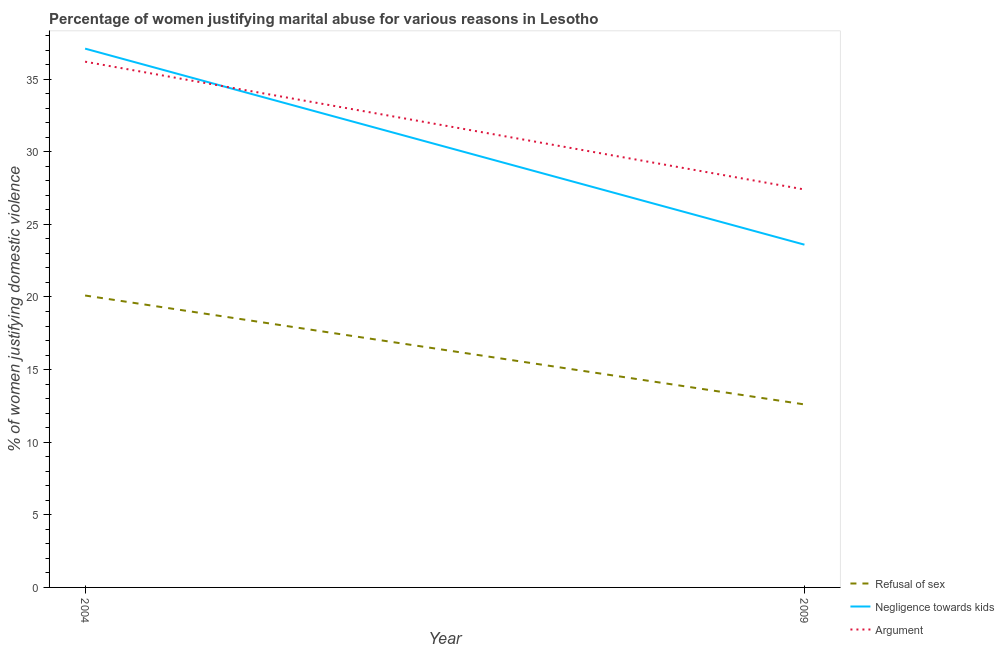How many different coloured lines are there?
Your answer should be very brief. 3. Does the line corresponding to percentage of women justifying domestic violence due to arguments intersect with the line corresponding to percentage of women justifying domestic violence due to negligence towards kids?
Provide a succinct answer. Yes. What is the percentage of women justifying domestic violence due to negligence towards kids in 2004?
Provide a succinct answer. 37.1. Across all years, what is the maximum percentage of women justifying domestic violence due to refusal of sex?
Provide a short and direct response. 20.1. Across all years, what is the minimum percentage of women justifying domestic violence due to arguments?
Offer a terse response. 27.4. In which year was the percentage of women justifying domestic violence due to refusal of sex minimum?
Your response must be concise. 2009. What is the total percentage of women justifying domestic violence due to negligence towards kids in the graph?
Offer a very short reply. 60.7. What is the difference between the percentage of women justifying domestic violence due to negligence towards kids in 2004 and that in 2009?
Keep it short and to the point. 13.5. What is the average percentage of women justifying domestic violence due to negligence towards kids per year?
Offer a terse response. 30.35. In the year 2004, what is the difference between the percentage of women justifying domestic violence due to negligence towards kids and percentage of women justifying domestic violence due to arguments?
Provide a succinct answer. 0.9. What is the ratio of the percentage of women justifying domestic violence due to refusal of sex in 2004 to that in 2009?
Make the answer very short. 1.6. Is the percentage of women justifying domestic violence due to refusal of sex in 2004 less than that in 2009?
Your response must be concise. No. In how many years, is the percentage of women justifying domestic violence due to negligence towards kids greater than the average percentage of women justifying domestic violence due to negligence towards kids taken over all years?
Provide a succinct answer. 1. Does the percentage of women justifying domestic violence due to negligence towards kids monotonically increase over the years?
Keep it short and to the point. No. Is the percentage of women justifying domestic violence due to arguments strictly greater than the percentage of women justifying domestic violence due to negligence towards kids over the years?
Offer a terse response. No. Is the percentage of women justifying domestic violence due to refusal of sex strictly less than the percentage of women justifying domestic violence due to arguments over the years?
Provide a succinct answer. Yes. How many years are there in the graph?
Your response must be concise. 2. Where does the legend appear in the graph?
Give a very brief answer. Bottom right. How many legend labels are there?
Provide a short and direct response. 3. What is the title of the graph?
Make the answer very short. Percentage of women justifying marital abuse for various reasons in Lesotho. Does "Total employers" appear as one of the legend labels in the graph?
Provide a short and direct response. No. What is the label or title of the Y-axis?
Offer a terse response. % of women justifying domestic violence. What is the % of women justifying domestic violence in Refusal of sex in 2004?
Ensure brevity in your answer.  20.1. What is the % of women justifying domestic violence in Negligence towards kids in 2004?
Provide a short and direct response. 37.1. What is the % of women justifying domestic violence of Argument in 2004?
Your response must be concise. 36.2. What is the % of women justifying domestic violence of Refusal of sex in 2009?
Give a very brief answer. 12.6. What is the % of women justifying domestic violence in Negligence towards kids in 2009?
Your response must be concise. 23.6. What is the % of women justifying domestic violence of Argument in 2009?
Offer a terse response. 27.4. Across all years, what is the maximum % of women justifying domestic violence of Refusal of sex?
Provide a short and direct response. 20.1. Across all years, what is the maximum % of women justifying domestic violence of Negligence towards kids?
Your response must be concise. 37.1. Across all years, what is the maximum % of women justifying domestic violence of Argument?
Give a very brief answer. 36.2. Across all years, what is the minimum % of women justifying domestic violence in Refusal of sex?
Your answer should be compact. 12.6. Across all years, what is the minimum % of women justifying domestic violence of Negligence towards kids?
Your answer should be compact. 23.6. Across all years, what is the minimum % of women justifying domestic violence of Argument?
Keep it short and to the point. 27.4. What is the total % of women justifying domestic violence of Refusal of sex in the graph?
Offer a very short reply. 32.7. What is the total % of women justifying domestic violence in Negligence towards kids in the graph?
Your answer should be very brief. 60.7. What is the total % of women justifying domestic violence of Argument in the graph?
Offer a very short reply. 63.6. What is the difference between the % of women justifying domestic violence in Refusal of sex in 2004 and that in 2009?
Provide a succinct answer. 7.5. What is the difference between the % of women justifying domestic violence in Negligence towards kids in 2004 and that in 2009?
Ensure brevity in your answer.  13.5. What is the difference between the % of women justifying domestic violence in Refusal of sex in 2004 and the % of women justifying domestic violence in Argument in 2009?
Ensure brevity in your answer.  -7.3. What is the difference between the % of women justifying domestic violence of Negligence towards kids in 2004 and the % of women justifying domestic violence of Argument in 2009?
Your answer should be very brief. 9.7. What is the average % of women justifying domestic violence in Refusal of sex per year?
Give a very brief answer. 16.35. What is the average % of women justifying domestic violence in Negligence towards kids per year?
Your answer should be compact. 30.35. What is the average % of women justifying domestic violence in Argument per year?
Give a very brief answer. 31.8. In the year 2004, what is the difference between the % of women justifying domestic violence of Refusal of sex and % of women justifying domestic violence of Argument?
Your response must be concise. -16.1. In the year 2009, what is the difference between the % of women justifying domestic violence of Refusal of sex and % of women justifying domestic violence of Negligence towards kids?
Keep it short and to the point. -11. In the year 2009, what is the difference between the % of women justifying domestic violence of Refusal of sex and % of women justifying domestic violence of Argument?
Make the answer very short. -14.8. In the year 2009, what is the difference between the % of women justifying domestic violence in Negligence towards kids and % of women justifying domestic violence in Argument?
Keep it short and to the point. -3.8. What is the ratio of the % of women justifying domestic violence in Refusal of sex in 2004 to that in 2009?
Provide a succinct answer. 1.6. What is the ratio of the % of women justifying domestic violence in Negligence towards kids in 2004 to that in 2009?
Your answer should be very brief. 1.57. What is the ratio of the % of women justifying domestic violence of Argument in 2004 to that in 2009?
Your answer should be compact. 1.32. What is the difference between the highest and the second highest % of women justifying domestic violence of Refusal of sex?
Your response must be concise. 7.5. What is the difference between the highest and the second highest % of women justifying domestic violence of Negligence towards kids?
Your answer should be very brief. 13.5. What is the difference between the highest and the second highest % of women justifying domestic violence of Argument?
Your response must be concise. 8.8. What is the difference between the highest and the lowest % of women justifying domestic violence in Negligence towards kids?
Your response must be concise. 13.5. What is the difference between the highest and the lowest % of women justifying domestic violence of Argument?
Make the answer very short. 8.8. 